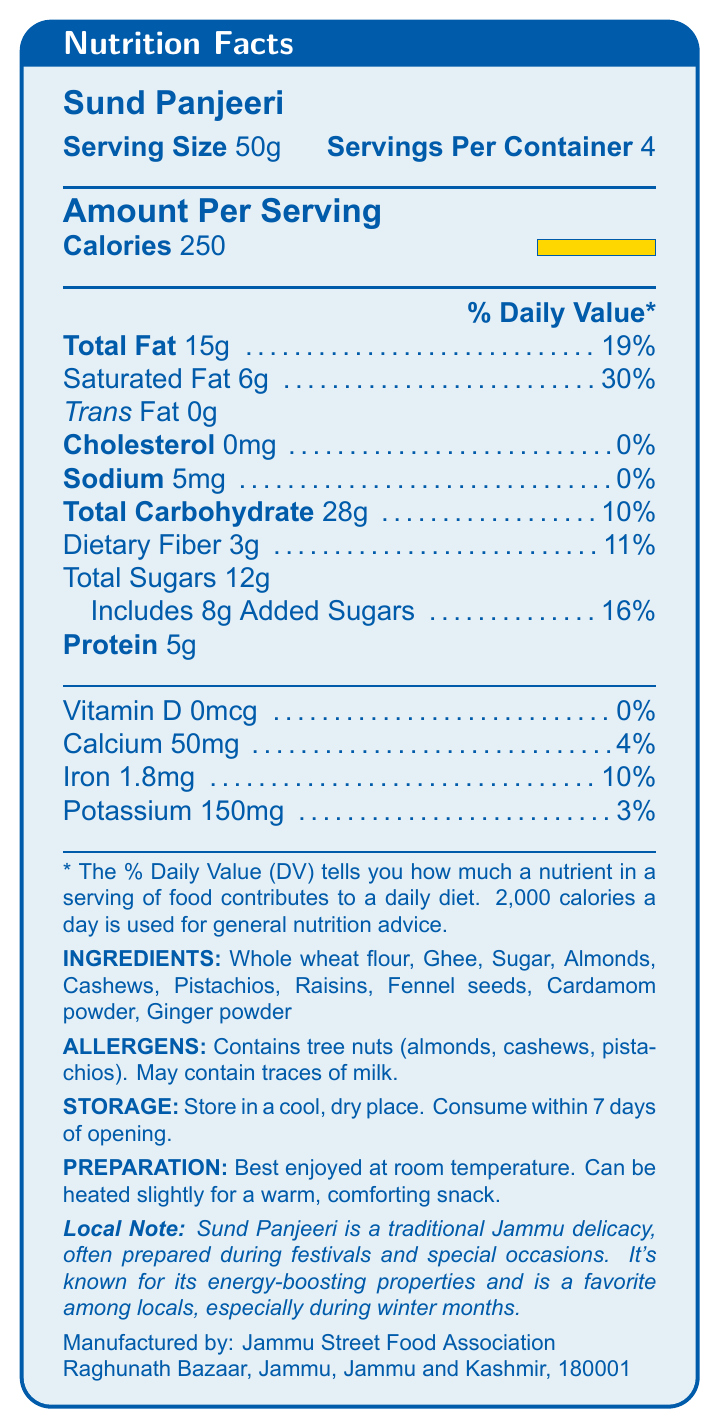what is the serving size of Sund Panjeeri? The document specifies that the serving size is 50g.
Answer: 50g how many servings are there in one container? The document states that there are 4 servings per container.
Answer: 4 what is the total amount of fat per serving? The document lists the total fat as 15g per serving.
Answer: 15g what is the percentage of the daily value for saturated fat? The document indicates that the saturated fat content is 30% of the daily value.
Answer: 30% how much dietary fiber is in one serving? The document mentions that there are 3g of dietary fiber per serving.
Answer: 3g which ingredient is not a tree nut? A. Almonds B. Cashews C. Pistachios D. Raisins Raisins are not a tree nut, while almonds, cashews, and pistachios are.
Answer: D. Raisins how much calcium does one serving provide? A. 0% B. 3% C. 4% D. 10% The document states that one serving provides 4% of the daily value of calcium.
Answer: C. 4% does Sund Panjeeri contain any added sugars? The document specifies that Sund Panjeeri includes 8g of added sugars.
Answer: Yes is this product suitable for someone with a tree nut allergy? The document's allergen section states that the product contains tree nuts (almonds, cashews, pistachios).
Answer: No describe the main idea of the document. The document outlines the nutritional profile of Sund Panjeeri, such as calories, fat, proteins, and carbohydrates, as well as its ingredients and allergens. It also includes storage and preparation instructions, along with a note on its cultural significance in Jammu.
Answer: The document provides detailed nutrition information about Sund Panjeeri, a popular street food from Jammu, including serving size, calories, macronutrients, vitamins, minerals, ingredients, allergens, and preparation instructions. what is the exact address of the manufacturer? The document specifies that the manufacturer, Jammu Street Food Association, is located at Raghunath Bazaar, Jammu, Jammu and Kashmir, 180001.
Answer: Raghunath Bazaar, Jammu, Jammu and Kashmir, 180001 how many grams of protein are in one serving? The document states that there are 5g of protein per serving.
Answer: 5g how much iron does one serving provide? The document lists that one serving provides 1.8mg of iron.
Answer: 1.8mg can you determine the total calories in the entire container? Since one serving is 250 calories and there are 4 servings per container, the total calories are 250 * 4 = 1000 calories.
Answer: 1000 calories what is the local significance of Sund Panjeeri? The document's local note section explains that Sund Panjeeri is a traditional delicacy in Jammu, celebrated for its energy-boosting benefits and cultural significance.
Answer: Sund Panjeeri is a traditional Jammu delicacy, often prepared during festivals and special occasions, known for its energy-boosting properties and popularity during winter months. does Sund Panjeeri contain any cholesterol? The document indicates that Sund Panjeeri contains 0mg of cholesterol.
Answer: No are there any preparation instructions given? The document provides preparation instructions, stating that Sund Panjeeri is best enjoyed at room temperature and can be heated slightly for a warm, comforting snack.
Answer: Yes what is the name of the product? The document clearly states that the name of the product is Sund Panjeeri.
Answer: Sund Panjeeri how should Sund Panjeeri be stored? A. In the refrigerator B. In a cool, dry place C. In the freezer D. At room temperature The document advises storing Sund Panjeeri in a cool, dry place.
Answer: B. In a cool, dry place can you confirm the exact amount of potassium per serving? The document specifies that there are 150mg of potassium per serving.
Answer: 150mg does this product contain any milk? The document's allergen section mentions that it may contain traces of milk.
Answer: May contain traces what is the total carbohydrate content per serving? The document lists the total carbohydrate content as 28g per serving.
Answer: 28g can we determine the exact recipe for Sund Panjeeri from this document? The document provides a list of ingredients but does not include the exact amounts or preparation steps for the recipe.
Answer: No 